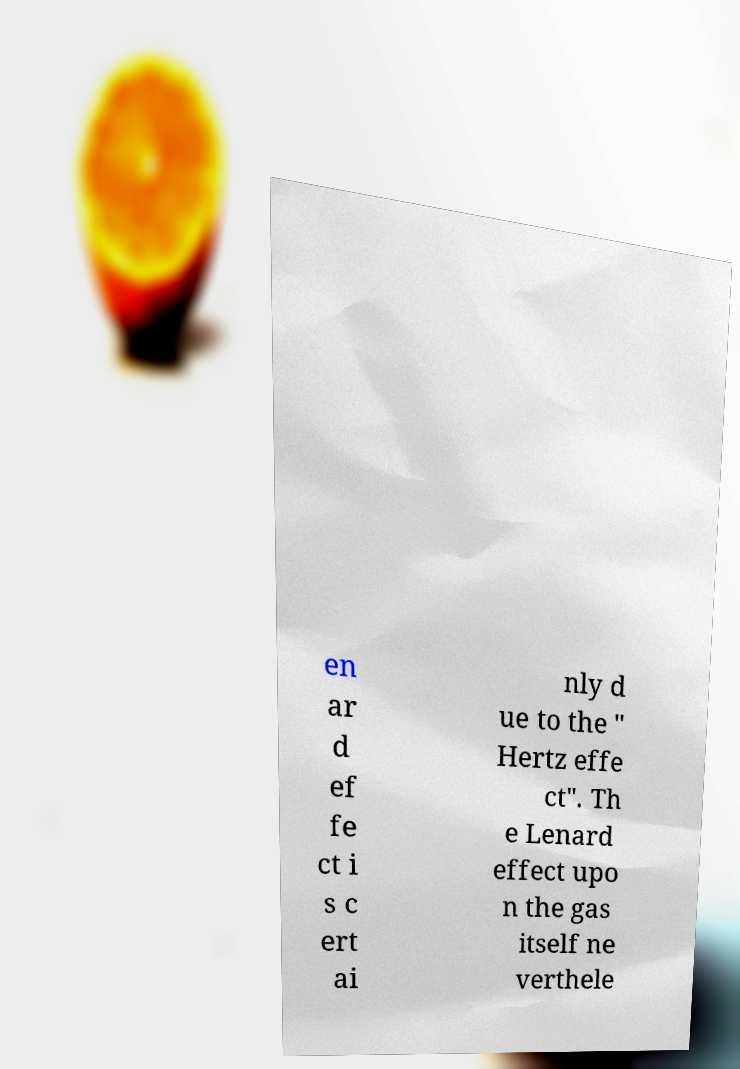Please identify and transcribe the text found in this image. en ar d ef fe ct i s c ert ai nly d ue to the " Hertz effe ct". Th e Lenard effect upo n the gas itself ne verthele 